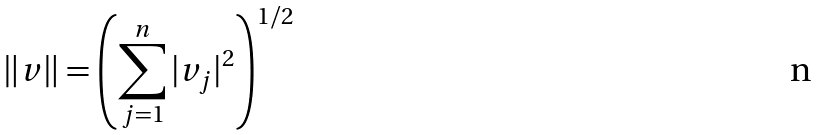Convert formula to latex. <formula><loc_0><loc_0><loc_500><loc_500>\| v \| = \left ( \sum _ { j = 1 } ^ { n } | v _ { j } | ^ { 2 } \right ) ^ { 1 / 2 }</formula> 